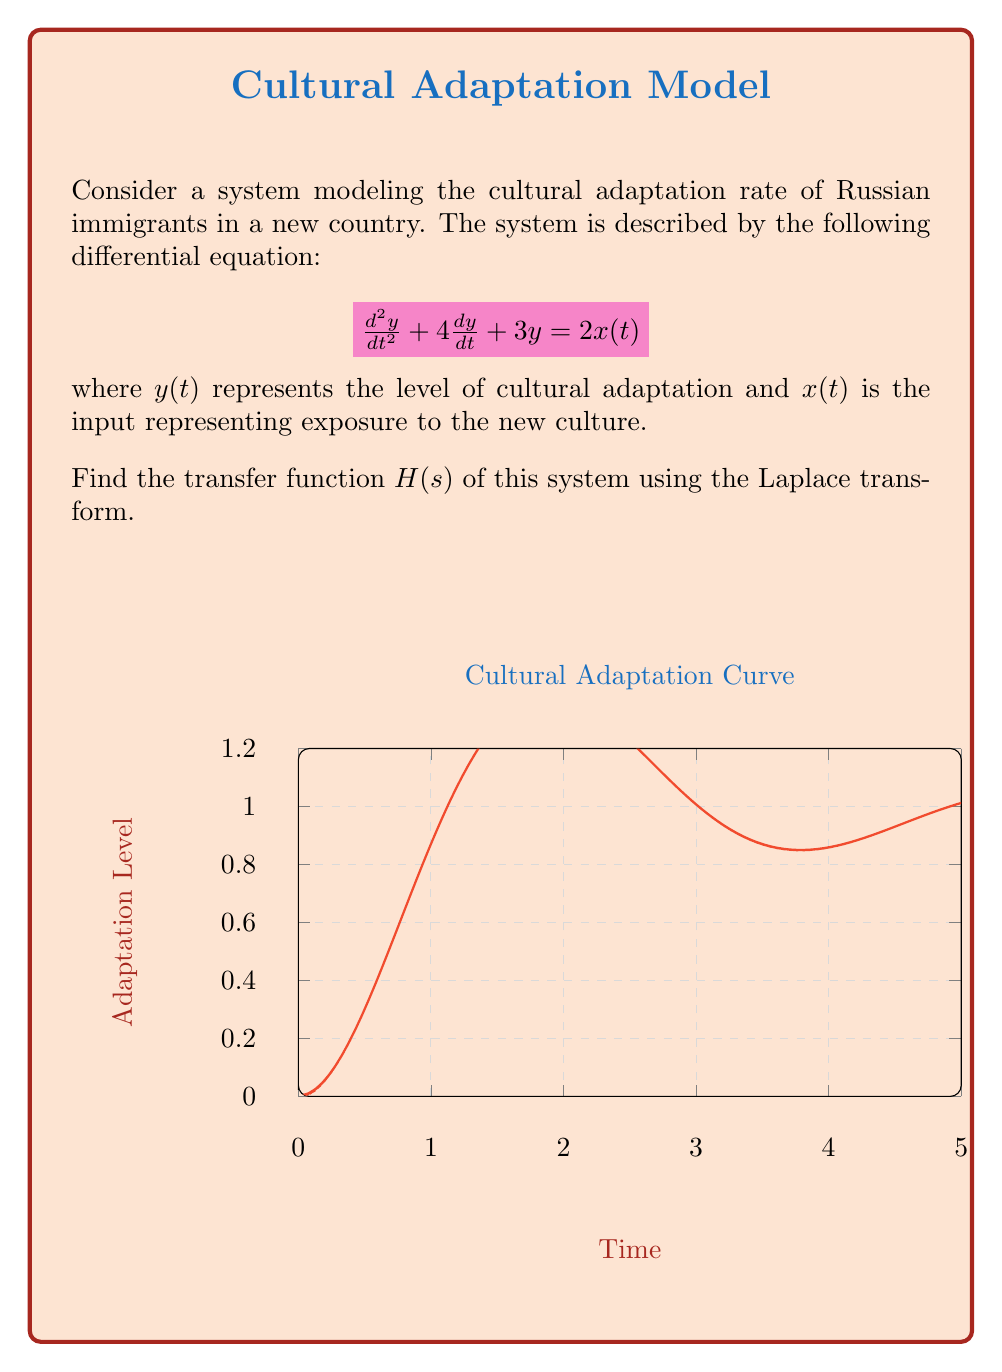What is the answer to this math problem? To find the transfer function, we need to apply the Laplace transform to both sides of the differential equation and then solve for $Y(s)/X(s)$.

Step 1: Apply the Laplace transform to the differential equation.
$$\mathcal{L}\{\frac{d^2y}{dt^2} + 4\frac{dy}{dt} + 3y\} = \mathcal{L}\{2x(t)\}$$

Step 2: Use Laplace transform properties:
$$[s^2Y(s) - sy(0) - y'(0)] + 4[sY(s) - y(0)] + 3Y(s) = 2X(s)$$

Step 3: Assume zero initial conditions (y(0) = y'(0) = 0):
$$s^2Y(s) + 4sY(s) + 3Y(s) = 2X(s)$$

Step 4: Factor out Y(s):
$$(s^2 + 4s + 3)Y(s) = 2X(s)$$

Step 5: Solve for Y(s)/X(s) to get the transfer function H(s):
$$H(s) = \frac{Y(s)}{X(s)} = \frac{2}{s^2 + 4s + 3}$$

The transfer function represents how the system responds to cultural exposure in the Laplace domain.
Answer: $$H(s) = \frac{2}{s^2 + 4s + 3}$$ 